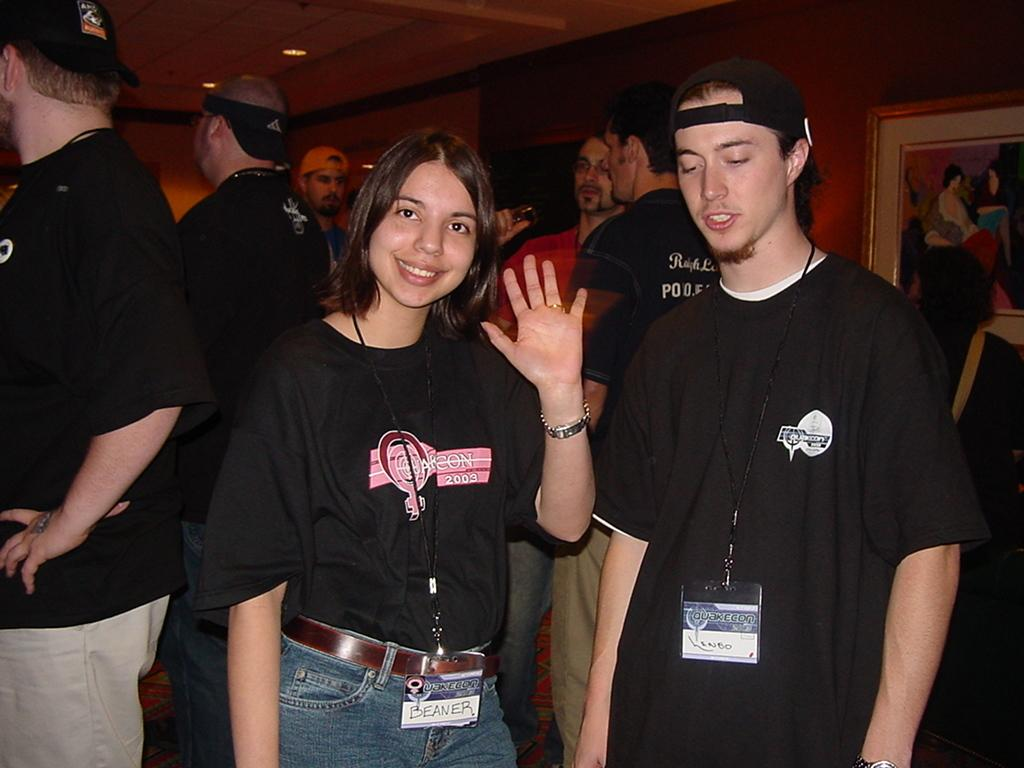What is happening in the image? There are people standing in the image. What can be seen in the background of the image? There is a wall in the background of the image. What is on the wall? There is a portrait on the wall. Can you describe the clothing of one of the people in the image? A man in the front is wearing a cap. What type of offer is the snake making to the people in the image? There is no snake present in the image, so it is not possible to determine what type of offer the snake might be making. 